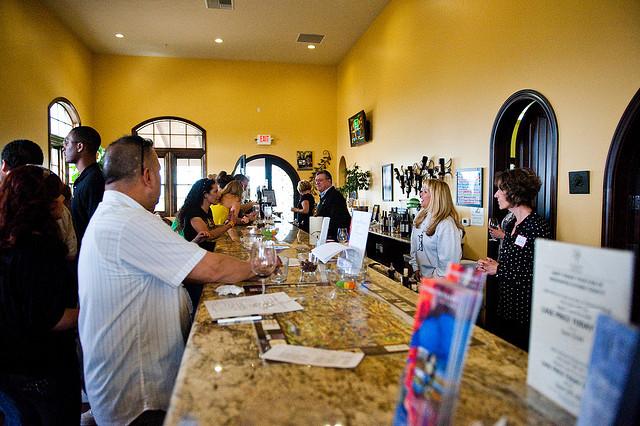Are the lights on in the room?
Answer briefly. Yes. How many women are behind the bar?
Give a very brief answer. 3. Is this a bar?
Be succinct. Yes. The number of people standing is?
Answer briefly. 10. 